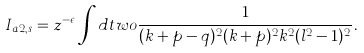Convert formula to latex. <formula><loc_0><loc_0><loc_500><loc_500>I _ { a 2 , s } = z ^ { - \epsilon } \int d t w o \frac { 1 } { ( k + p - q ) ^ { 2 } ( k + p ) ^ { 2 } k ^ { 2 } ( l ^ { 2 } - 1 ) ^ { 2 } } .</formula> 